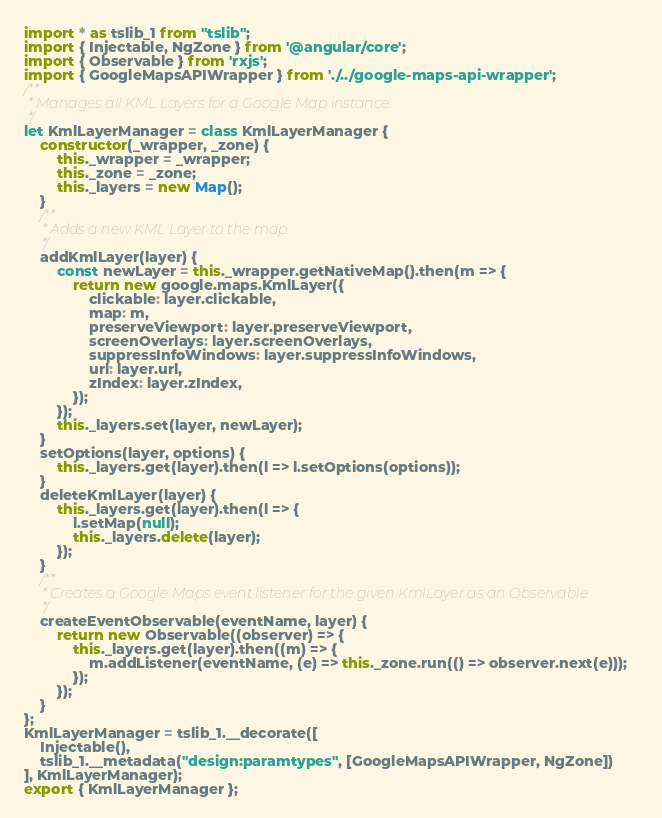Convert code to text. <code><loc_0><loc_0><loc_500><loc_500><_JavaScript_>import * as tslib_1 from "tslib";
import { Injectable, NgZone } from '@angular/core';
import { Observable } from 'rxjs';
import { GoogleMapsAPIWrapper } from './../google-maps-api-wrapper';
/**
 * Manages all KML Layers for a Google Map instance.
 */
let KmlLayerManager = class KmlLayerManager {
    constructor(_wrapper, _zone) {
        this._wrapper = _wrapper;
        this._zone = _zone;
        this._layers = new Map();
    }
    /**
     * Adds a new KML Layer to the map.
     */
    addKmlLayer(layer) {
        const newLayer = this._wrapper.getNativeMap().then(m => {
            return new google.maps.KmlLayer({
                clickable: layer.clickable,
                map: m,
                preserveViewport: layer.preserveViewport,
                screenOverlays: layer.screenOverlays,
                suppressInfoWindows: layer.suppressInfoWindows,
                url: layer.url,
                zIndex: layer.zIndex,
            });
        });
        this._layers.set(layer, newLayer);
    }
    setOptions(layer, options) {
        this._layers.get(layer).then(l => l.setOptions(options));
    }
    deleteKmlLayer(layer) {
        this._layers.get(layer).then(l => {
            l.setMap(null);
            this._layers.delete(layer);
        });
    }
    /**
     * Creates a Google Maps event listener for the given KmlLayer as an Observable
     */
    createEventObservable(eventName, layer) {
        return new Observable((observer) => {
            this._layers.get(layer).then((m) => {
                m.addListener(eventName, (e) => this._zone.run(() => observer.next(e)));
            });
        });
    }
};
KmlLayerManager = tslib_1.__decorate([
    Injectable(),
    tslib_1.__metadata("design:paramtypes", [GoogleMapsAPIWrapper, NgZone])
], KmlLayerManager);
export { KmlLayerManager };</code> 